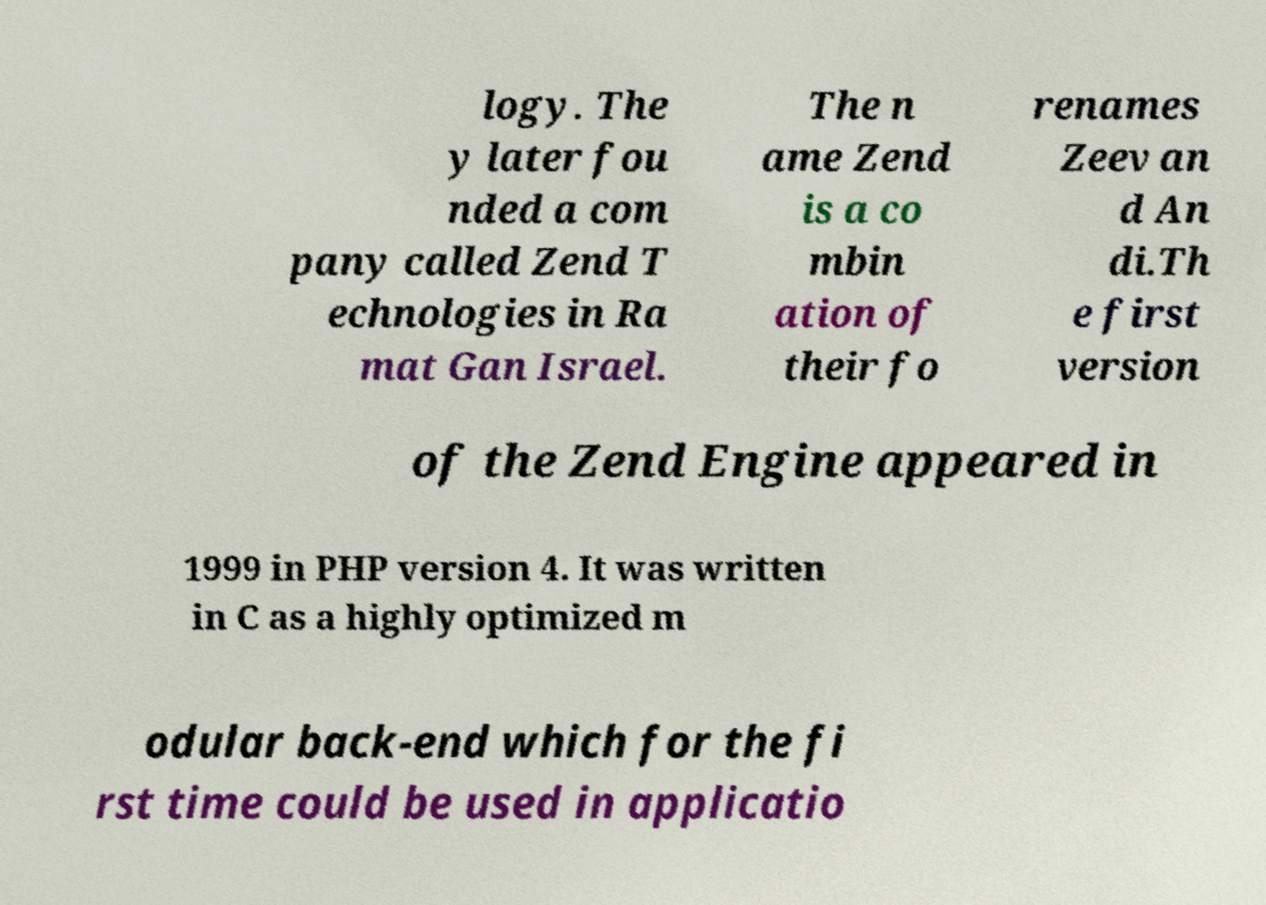Please identify and transcribe the text found in this image. logy. The y later fou nded a com pany called Zend T echnologies in Ra mat Gan Israel. The n ame Zend is a co mbin ation of their fo renames Zeev an d An di.Th e first version of the Zend Engine appeared in 1999 in PHP version 4. It was written in C as a highly optimized m odular back-end which for the fi rst time could be used in applicatio 